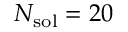<formula> <loc_0><loc_0><loc_500><loc_500>N _ { s o l } = 2 0</formula> 